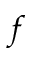Convert formula to latex. <formula><loc_0><loc_0><loc_500><loc_500>f</formula> 